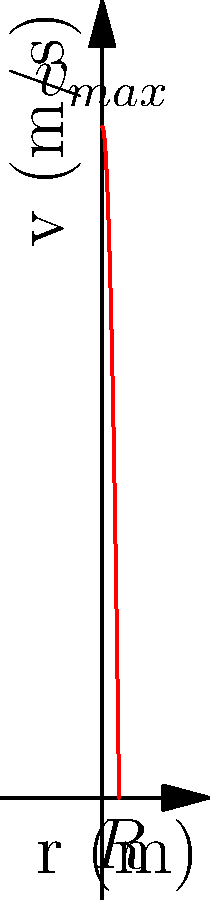Given the velocity profile of laminar flow in a circular pipe as shown in the graph, where $v_{max}$ is 2 m/s and the pipe radius $R$ is 0.05 m, calculate the average velocity $v_{avg}$ of the fluid. Assume the flow follows the parabolic profile given by the equation:

$$v(r) = v_{max}\left(1-\left(\frac{r}{R}\right)^2\right)$$

Express your answer in m/s, rounded to two decimal places. To find the average velocity, we need to integrate the velocity profile over the pipe's cross-sectional area and divide by the total area. Here's the step-by-step process:

1) The average velocity is given by:
   $$v_{avg} = \frac{1}{\pi R^2} \int_0^R v(r) \cdot 2\pi r \, dr$$

2) Substitute the given velocity profile:
   $$v_{avg} = \frac{1}{\pi R^2} \int_0^R v_{max}\left(1-\left(\frac{r}{R}\right)^2\right) \cdot 2\pi r \, dr$$

3) Simplify and rearrange:
   $$v_{avg} = \frac{2v_{max}}{R^2} \int_0^R \left(r-\frac{r^3}{R^2}\right) \, dr$$

4) Integrate:
   $$v_{avg} = \frac{2v_{max}}{R^2} \left[\frac{r^2}{2}-\frac{r^4}{4R^2}\right]_0^R$$

5) Evaluate the limits:
   $$v_{avg} = \frac{2v_{max}}{R^2} \left[\frac{R^2}{2}-\frac{R^4}{4R^2}\right] = v_{max}\left(1-\frac{1}{4}\right)$$

6) Simplify:
   $$v_{avg} = \frac{1}{2}v_{max}$$

7) Substitute the given value of $v_{max} = 2$ m/s:
   $$v_{avg} = \frac{1}{2} \cdot 2 = 1$$ m/s

Therefore, the average velocity is 1 m/s.
Answer: 1.00 m/s 